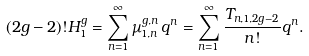Convert formula to latex. <formula><loc_0><loc_0><loc_500><loc_500>( 2 g - 2 ) ! H _ { 1 } ^ { g } = \sum _ { n = 1 } ^ { \infty } \mu _ { 1 , n } ^ { g , n } \, q ^ { n } = \sum _ { n = 1 } ^ { \infty } \frac { T _ { n , 1 , 2 g - 2 } } { n ! } q ^ { n } .</formula> 